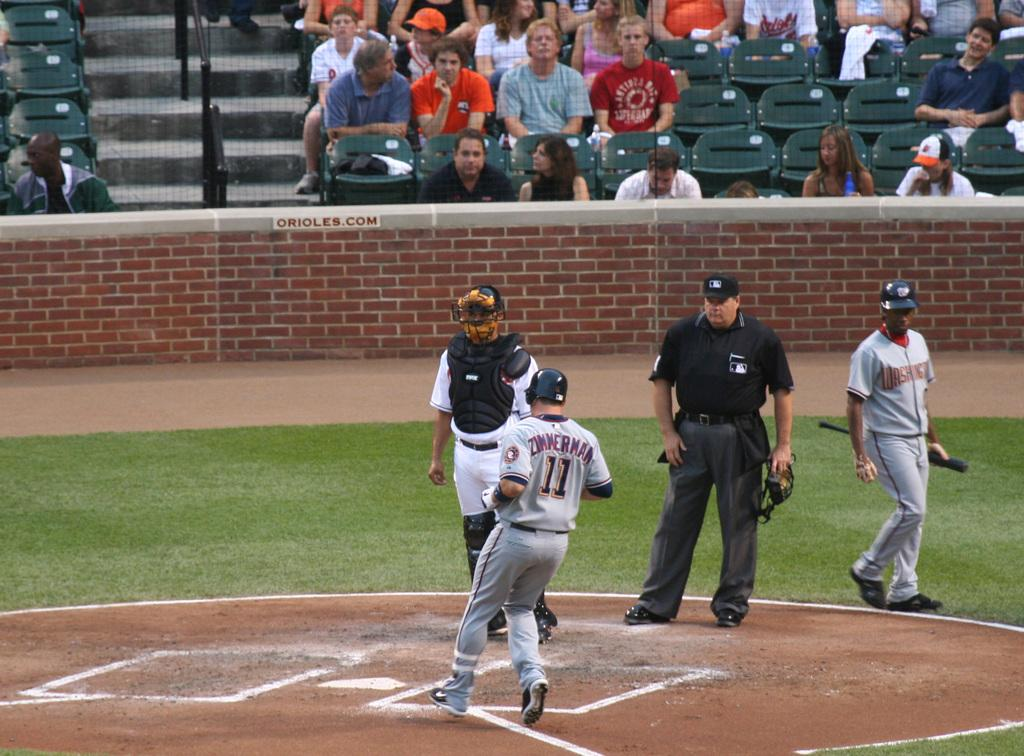<image>
Write a terse but informative summary of the picture. Number 11 is approaching home plate as the catcher looks on. 